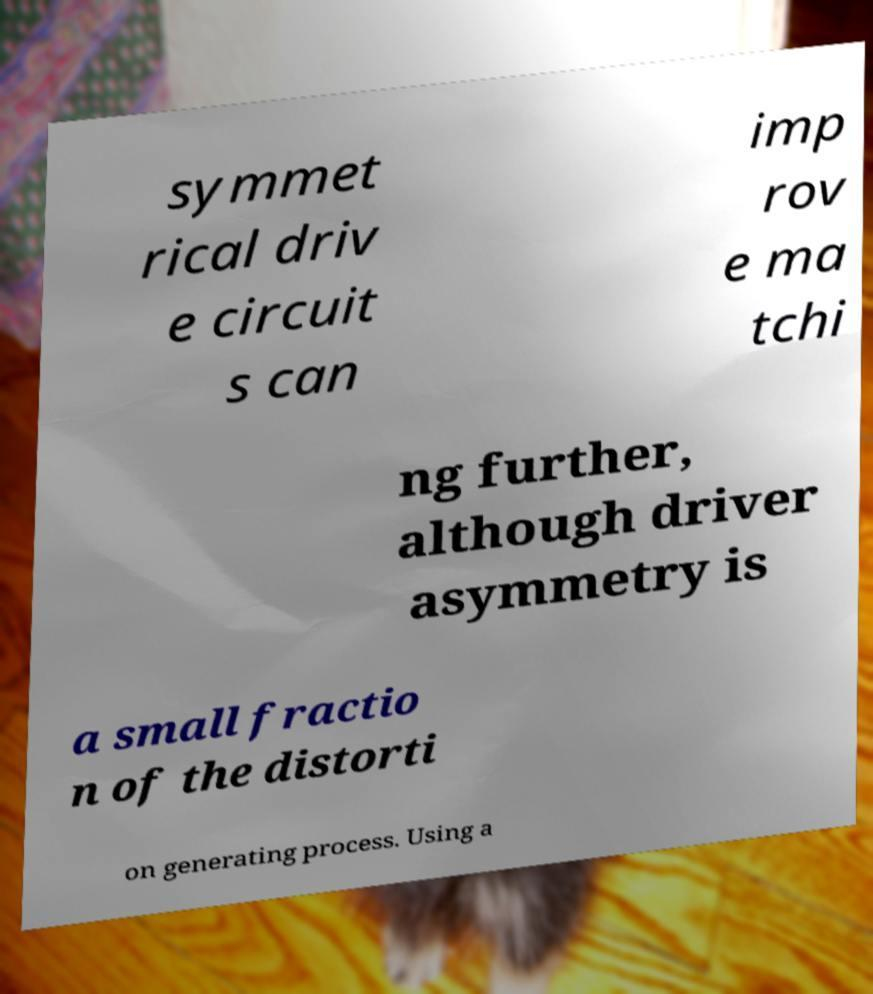Could you extract and type out the text from this image? symmet rical driv e circuit s can imp rov e ma tchi ng further, although driver asymmetry is a small fractio n of the distorti on generating process. Using a 